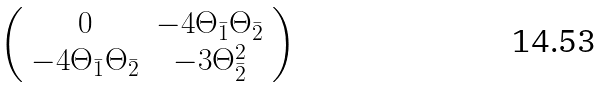<formula> <loc_0><loc_0><loc_500><loc_500>\left ( \begin{array} { c c } 0 & - 4 \Theta _ { \bar { 1 } } \Theta _ { \bar { 2 } } \\ - 4 \Theta _ { \bar { 1 } } \Theta _ { \bar { 2 } } & - 3 \Theta _ { \bar { 2 } } ^ { 2 } \end{array} \right )</formula> 